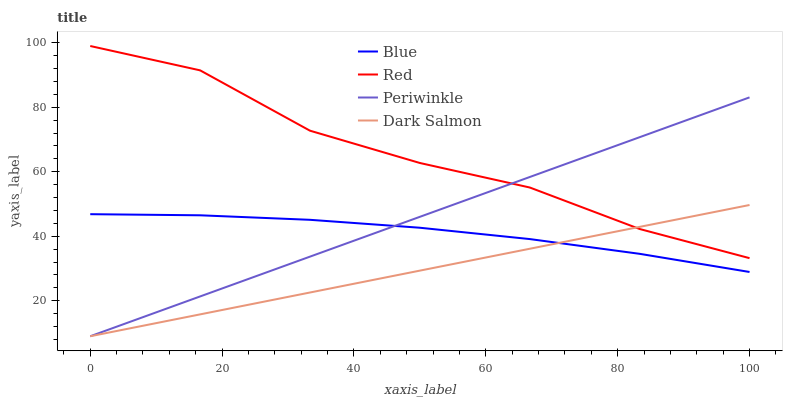Does Dark Salmon have the minimum area under the curve?
Answer yes or no. Yes. Does Red have the maximum area under the curve?
Answer yes or no. Yes. Does Periwinkle have the minimum area under the curve?
Answer yes or no. No. Does Periwinkle have the maximum area under the curve?
Answer yes or no. No. Is Dark Salmon the smoothest?
Answer yes or no. Yes. Is Red the roughest?
Answer yes or no. Yes. Is Periwinkle the smoothest?
Answer yes or no. No. Is Periwinkle the roughest?
Answer yes or no. No. Does Red have the lowest value?
Answer yes or no. No. Does Red have the highest value?
Answer yes or no. Yes. Does Periwinkle have the highest value?
Answer yes or no. No. Is Blue less than Red?
Answer yes or no. Yes. Is Red greater than Blue?
Answer yes or no. Yes. Does Periwinkle intersect Blue?
Answer yes or no. Yes. Is Periwinkle less than Blue?
Answer yes or no. No. Is Periwinkle greater than Blue?
Answer yes or no. No. Does Blue intersect Red?
Answer yes or no. No. 